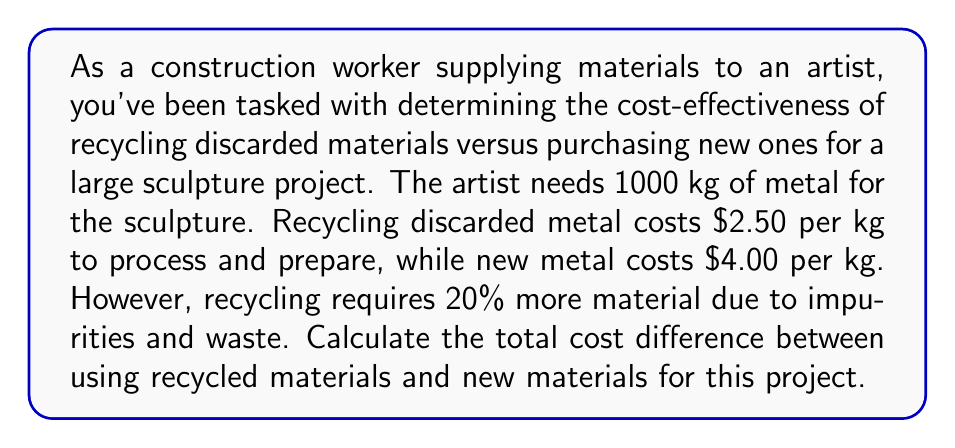Solve this math problem. Let's approach this problem step-by-step:

1. Calculate the amount of recycled material needed:
   $$1000 \text{ kg} \times 1.20 = 1200 \text{ kg}$$
   We need 20% more recycled material, so 1200 kg in total.

2. Calculate the cost of using recycled material:
   $$1200 \text{ kg} \times \$2.50/\text{kg} = \$3000$$

3. Calculate the cost of using new material:
   $$1000 \text{ kg} \times \$4.00/\text{kg} = \$4000$$

4. Calculate the cost difference:
   $$\$4000 - \$3000 = \$1000$$

Therefore, using recycled materials would save $1000 for this project.
Answer: $1000 